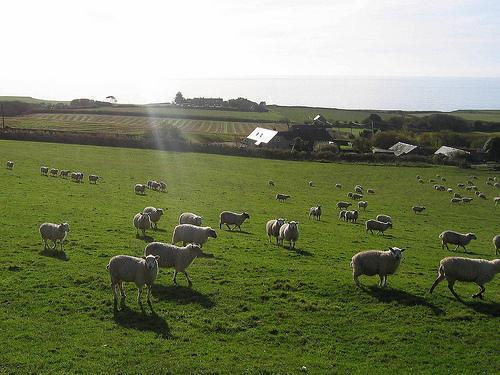How many ears does sheep have?
Give a very brief answer. 2. 